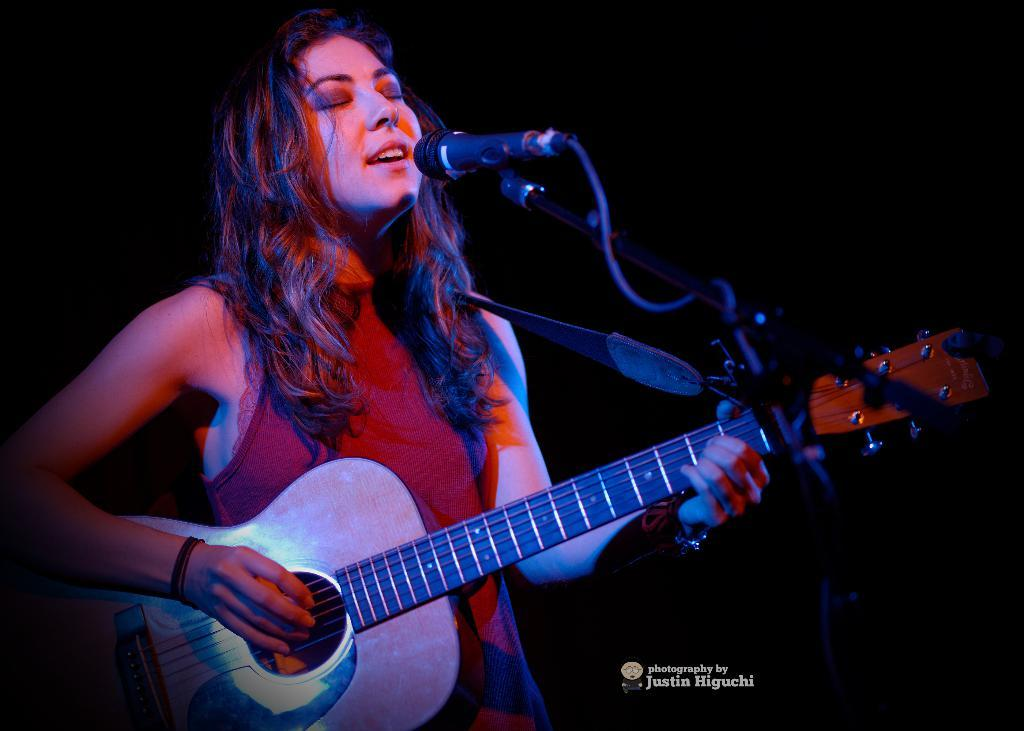Who is the main subject in the image? There is a woman in the image. What is the woman doing in the image? The woman is playing a guitar and singing. What object is present in the image that is commonly used for amplifying sound? There is a microphone in the image. What type of locket is the woman wearing around her neck in the image? There is no locket visible around the woman's neck in the image. How does the woman use the comb to style her hair while playing the guitar? The woman is not using a comb in the image; she is playing the guitar and singing. 